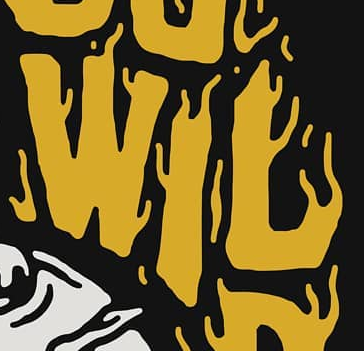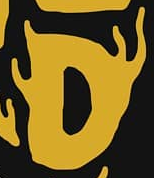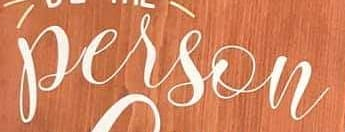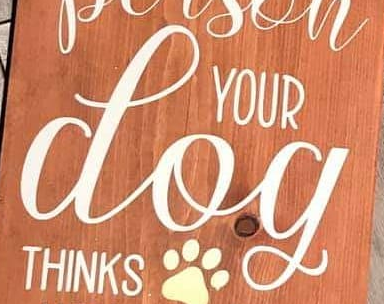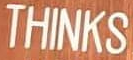What words can you see in these images in sequence, separated by a semicolon? WIL; D; person; dog; THINKS 